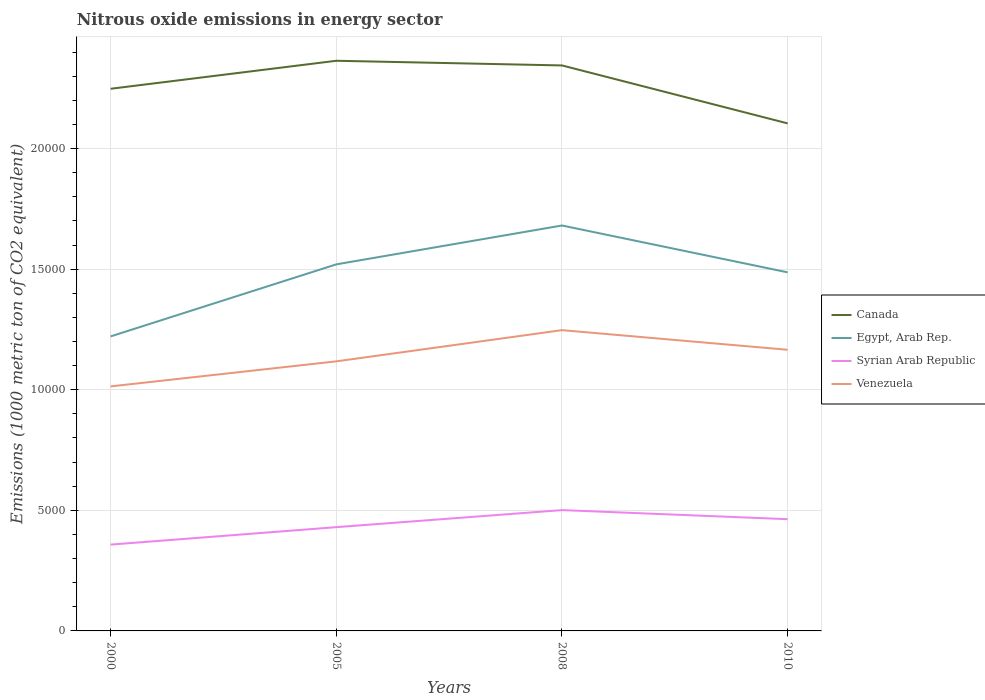Across all years, what is the maximum amount of nitrous oxide emitted in Egypt, Arab Rep.?
Give a very brief answer. 1.22e+04. In which year was the amount of nitrous oxide emitted in Venezuela maximum?
Your answer should be compact. 2000. What is the total amount of nitrous oxide emitted in Venezuela in the graph?
Provide a short and direct response. -1518.6. What is the difference between the highest and the second highest amount of nitrous oxide emitted in Venezuela?
Provide a short and direct response. 2332.1. How many years are there in the graph?
Provide a short and direct response. 4. What is the difference between two consecutive major ticks on the Y-axis?
Offer a terse response. 5000. Where does the legend appear in the graph?
Ensure brevity in your answer.  Center right. How many legend labels are there?
Offer a terse response. 4. What is the title of the graph?
Keep it short and to the point. Nitrous oxide emissions in energy sector. What is the label or title of the X-axis?
Provide a succinct answer. Years. What is the label or title of the Y-axis?
Give a very brief answer. Emissions (1000 metric ton of CO2 equivalent). What is the Emissions (1000 metric ton of CO2 equivalent) in Canada in 2000?
Provide a short and direct response. 2.25e+04. What is the Emissions (1000 metric ton of CO2 equivalent) in Egypt, Arab Rep. in 2000?
Your answer should be compact. 1.22e+04. What is the Emissions (1000 metric ton of CO2 equivalent) of Syrian Arab Republic in 2000?
Provide a succinct answer. 3579.1. What is the Emissions (1000 metric ton of CO2 equivalent) of Venezuela in 2000?
Provide a succinct answer. 1.01e+04. What is the Emissions (1000 metric ton of CO2 equivalent) in Canada in 2005?
Offer a very short reply. 2.36e+04. What is the Emissions (1000 metric ton of CO2 equivalent) in Egypt, Arab Rep. in 2005?
Provide a short and direct response. 1.52e+04. What is the Emissions (1000 metric ton of CO2 equivalent) in Syrian Arab Republic in 2005?
Offer a very short reply. 4302.7. What is the Emissions (1000 metric ton of CO2 equivalent) in Venezuela in 2005?
Offer a terse response. 1.12e+04. What is the Emissions (1000 metric ton of CO2 equivalent) in Canada in 2008?
Keep it short and to the point. 2.34e+04. What is the Emissions (1000 metric ton of CO2 equivalent) in Egypt, Arab Rep. in 2008?
Make the answer very short. 1.68e+04. What is the Emissions (1000 metric ton of CO2 equivalent) in Syrian Arab Republic in 2008?
Ensure brevity in your answer.  5009.9. What is the Emissions (1000 metric ton of CO2 equivalent) of Venezuela in 2008?
Your answer should be very brief. 1.25e+04. What is the Emissions (1000 metric ton of CO2 equivalent) in Canada in 2010?
Your answer should be compact. 2.10e+04. What is the Emissions (1000 metric ton of CO2 equivalent) of Egypt, Arab Rep. in 2010?
Offer a very short reply. 1.49e+04. What is the Emissions (1000 metric ton of CO2 equivalent) in Syrian Arab Republic in 2010?
Your response must be concise. 4633.1. What is the Emissions (1000 metric ton of CO2 equivalent) of Venezuela in 2010?
Make the answer very short. 1.17e+04. Across all years, what is the maximum Emissions (1000 metric ton of CO2 equivalent) in Canada?
Provide a short and direct response. 2.36e+04. Across all years, what is the maximum Emissions (1000 metric ton of CO2 equivalent) in Egypt, Arab Rep.?
Provide a short and direct response. 1.68e+04. Across all years, what is the maximum Emissions (1000 metric ton of CO2 equivalent) in Syrian Arab Republic?
Offer a very short reply. 5009.9. Across all years, what is the maximum Emissions (1000 metric ton of CO2 equivalent) in Venezuela?
Your answer should be compact. 1.25e+04. Across all years, what is the minimum Emissions (1000 metric ton of CO2 equivalent) in Canada?
Your answer should be very brief. 2.10e+04. Across all years, what is the minimum Emissions (1000 metric ton of CO2 equivalent) of Egypt, Arab Rep.?
Your answer should be very brief. 1.22e+04. Across all years, what is the minimum Emissions (1000 metric ton of CO2 equivalent) of Syrian Arab Republic?
Provide a short and direct response. 3579.1. Across all years, what is the minimum Emissions (1000 metric ton of CO2 equivalent) of Venezuela?
Provide a short and direct response. 1.01e+04. What is the total Emissions (1000 metric ton of CO2 equivalent) in Canada in the graph?
Your answer should be very brief. 9.06e+04. What is the total Emissions (1000 metric ton of CO2 equivalent) in Egypt, Arab Rep. in the graph?
Provide a succinct answer. 5.91e+04. What is the total Emissions (1000 metric ton of CO2 equivalent) in Syrian Arab Republic in the graph?
Your response must be concise. 1.75e+04. What is the total Emissions (1000 metric ton of CO2 equivalent) of Venezuela in the graph?
Provide a succinct answer. 4.54e+04. What is the difference between the Emissions (1000 metric ton of CO2 equivalent) in Canada in 2000 and that in 2005?
Make the answer very short. -1161.2. What is the difference between the Emissions (1000 metric ton of CO2 equivalent) of Egypt, Arab Rep. in 2000 and that in 2005?
Your response must be concise. -2987.6. What is the difference between the Emissions (1000 metric ton of CO2 equivalent) of Syrian Arab Republic in 2000 and that in 2005?
Make the answer very short. -723.6. What is the difference between the Emissions (1000 metric ton of CO2 equivalent) in Venezuela in 2000 and that in 2005?
Your answer should be very brief. -1038.4. What is the difference between the Emissions (1000 metric ton of CO2 equivalent) in Canada in 2000 and that in 2008?
Provide a succinct answer. -967.5. What is the difference between the Emissions (1000 metric ton of CO2 equivalent) in Egypt, Arab Rep. in 2000 and that in 2008?
Provide a short and direct response. -4599. What is the difference between the Emissions (1000 metric ton of CO2 equivalent) in Syrian Arab Republic in 2000 and that in 2008?
Make the answer very short. -1430.8. What is the difference between the Emissions (1000 metric ton of CO2 equivalent) in Venezuela in 2000 and that in 2008?
Ensure brevity in your answer.  -2332.1. What is the difference between the Emissions (1000 metric ton of CO2 equivalent) in Canada in 2000 and that in 2010?
Make the answer very short. 1435.7. What is the difference between the Emissions (1000 metric ton of CO2 equivalent) of Egypt, Arab Rep. in 2000 and that in 2010?
Offer a terse response. -2656.4. What is the difference between the Emissions (1000 metric ton of CO2 equivalent) in Syrian Arab Republic in 2000 and that in 2010?
Your answer should be very brief. -1054. What is the difference between the Emissions (1000 metric ton of CO2 equivalent) in Venezuela in 2000 and that in 2010?
Your answer should be very brief. -1518.6. What is the difference between the Emissions (1000 metric ton of CO2 equivalent) of Canada in 2005 and that in 2008?
Your answer should be very brief. 193.7. What is the difference between the Emissions (1000 metric ton of CO2 equivalent) of Egypt, Arab Rep. in 2005 and that in 2008?
Offer a very short reply. -1611.4. What is the difference between the Emissions (1000 metric ton of CO2 equivalent) in Syrian Arab Republic in 2005 and that in 2008?
Your answer should be compact. -707.2. What is the difference between the Emissions (1000 metric ton of CO2 equivalent) in Venezuela in 2005 and that in 2008?
Give a very brief answer. -1293.7. What is the difference between the Emissions (1000 metric ton of CO2 equivalent) in Canada in 2005 and that in 2010?
Your answer should be compact. 2596.9. What is the difference between the Emissions (1000 metric ton of CO2 equivalent) of Egypt, Arab Rep. in 2005 and that in 2010?
Your answer should be very brief. 331.2. What is the difference between the Emissions (1000 metric ton of CO2 equivalent) of Syrian Arab Republic in 2005 and that in 2010?
Make the answer very short. -330.4. What is the difference between the Emissions (1000 metric ton of CO2 equivalent) in Venezuela in 2005 and that in 2010?
Your answer should be very brief. -480.2. What is the difference between the Emissions (1000 metric ton of CO2 equivalent) in Canada in 2008 and that in 2010?
Your answer should be compact. 2403.2. What is the difference between the Emissions (1000 metric ton of CO2 equivalent) of Egypt, Arab Rep. in 2008 and that in 2010?
Your answer should be very brief. 1942.6. What is the difference between the Emissions (1000 metric ton of CO2 equivalent) in Syrian Arab Republic in 2008 and that in 2010?
Offer a terse response. 376.8. What is the difference between the Emissions (1000 metric ton of CO2 equivalent) in Venezuela in 2008 and that in 2010?
Provide a succinct answer. 813.5. What is the difference between the Emissions (1000 metric ton of CO2 equivalent) in Canada in 2000 and the Emissions (1000 metric ton of CO2 equivalent) in Egypt, Arab Rep. in 2005?
Your response must be concise. 7280.8. What is the difference between the Emissions (1000 metric ton of CO2 equivalent) of Canada in 2000 and the Emissions (1000 metric ton of CO2 equivalent) of Syrian Arab Republic in 2005?
Keep it short and to the point. 1.82e+04. What is the difference between the Emissions (1000 metric ton of CO2 equivalent) of Canada in 2000 and the Emissions (1000 metric ton of CO2 equivalent) of Venezuela in 2005?
Offer a terse response. 1.13e+04. What is the difference between the Emissions (1000 metric ton of CO2 equivalent) in Egypt, Arab Rep. in 2000 and the Emissions (1000 metric ton of CO2 equivalent) in Syrian Arab Republic in 2005?
Give a very brief answer. 7909.7. What is the difference between the Emissions (1000 metric ton of CO2 equivalent) in Egypt, Arab Rep. in 2000 and the Emissions (1000 metric ton of CO2 equivalent) in Venezuela in 2005?
Offer a terse response. 1034.4. What is the difference between the Emissions (1000 metric ton of CO2 equivalent) of Syrian Arab Republic in 2000 and the Emissions (1000 metric ton of CO2 equivalent) of Venezuela in 2005?
Offer a terse response. -7598.9. What is the difference between the Emissions (1000 metric ton of CO2 equivalent) of Canada in 2000 and the Emissions (1000 metric ton of CO2 equivalent) of Egypt, Arab Rep. in 2008?
Offer a very short reply. 5669.4. What is the difference between the Emissions (1000 metric ton of CO2 equivalent) of Canada in 2000 and the Emissions (1000 metric ton of CO2 equivalent) of Syrian Arab Republic in 2008?
Ensure brevity in your answer.  1.75e+04. What is the difference between the Emissions (1000 metric ton of CO2 equivalent) in Canada in 2000 and the Emissions (1000 metric ton of CO2 equivalent) in Venezuela in 2008?
Your response must be concise. 1.00e+04. What is the difference between the Emissions (1000 metric ton of CO2 equivalent) of Egypt, Arab Rep. in 2000 and the Emissions (1000 metric ton of CO2 equivalent) of Syrian Arab Republic in 2008?
Your answer should be very brief. 7202.5. What is the difference between the Emissions (1000 metric ton of CO2 equivalent) in Egypt, Arab Rep. in 2000 and the Emissions (1000 metric ton of CO2 equivalent) in Venezuela in 2008?
Give a very brief answer. -259.3. What is the difference between the Emissions (1000 metric ton of CO2 equivalent) in Syrian Arab Republic in 2000 and the Emissions (1000 metric ton of CO2 equivalent) in Venezuela in 2008?
Your response must be concise. -8892.6. What is the difference between the Emissions (1000 metric ton of CO2 equivalent) in Canada in 2000 and the Emissions (1000 metric ton of CO2 equivalent) in Egypt, Arab Rep. in 2010?
Keep it short and to the point. 7612. What is the difference between the Emissions (1000 metric ton of CO2 equivalent) in Canada in 2000 and the Emissions (1000 metric ton of CO2 equivalent) in Syrian Arab Republic in 2010?
Offer a terse response. 1.78e+04. What is the difference between the Emissions (1000 metric ton of CO2 equivalent) in Canada in 2000 and the Emissions (1000 metric ton of CO2 equivalent) in Venezuela in 2010?
Your answer should be very brief. 1.08e+04. What is the difference between the Emissions (1000 metric ton of CO2 equivalent) of Egypt, Arab Rep. in 2000 and the Emissions (1000 metric ton of CO2 equivalent) of Syrian Arab Republic in 2010?
Provide a short and direct response. 7579.3. What is the difference between the Emissions (1000 metric ton of CO2 equivalent) of Egypt, Arab Rep. in 2000 and the Emissions (1000 metric ton of CO2 equivalent) of Venezuela in 2010?
Your answer should be compact. 554.2. What is the difference between the Emissions (1000 metric ton of CO2 equivalent) in Syrian Arab Republic in 2000 and the Emissions (1000 metric ton of CO2 equivalent) in Venezuela in 2010?
Your answer should be compact. -8079.1. What is the difference between the Emissions (1000 metric ton of CO2 equivalent) in Canada in 2005 and the Emissions (1000 metric ton of CO2 equivalent) in Egypt, Arab Rep. in 2008?
Provide a succinct answer. 6830.6. What is the difference between the Emissions (1000 metric ton of CO2 equivalent) of Canada in 2005 and the Emissions (1000 metric ton of CO2 equivalent) of Syrian Arab Republic in 2008?
Your answer should be compact. 1.86e+04. What is the difference between the Emissions (1000 metric ton of CO2 equivalent) in Canada in 2005 and the Emissions (1000 metric ton of CO2 equivalent) in Venezuela in 2008?
Keep it short and to the point. 1.12e+04. What is the difference between the Emissions (1000 metric ton of CO2 equivalent) of Egypt, Arab Rep. in 2005 and the Emissions (1000 metric ton of CO2 equivalent) of Syrian Arab Republic in 2008?
Give a very brief answer. 1.02e+04. What is the difference between the Emissions (1000 metric ton of CO2 equivalent) in Egypt, Arab Rep. in 2005 and the Emissions (1000 metric ton of CO2 equivalent) in Venezuela in 2008?
Keep it short and to the point. 2728.3. What is the difference between the Emissions (1000 metric ton of CO2 equivalent) in Syrian Arab Republic in 2005 and the Emissions (1000 metric ton of CO2 equivalent) in Venezuela in 2008?
Make the answer very short. -8169. What is the difference between the Emissions (1000 metric ton of CO2 equivalent) of Canada in 2005 and the Emissions (1000 metric ton of CO2 equivalent) of Egypt, Arab Rep. in 2010?
Offer a very short reply. 8773.2. What is the difference between the Emissions (1000 metric ton of CO2 equivalent) in Canada in 2005 and the Emissions (1000 metric ton of CO2 equivalent) in Syrian Arab Republic in 2010?
Provide a succinct answer. 1.90e+04. What is the difference between the Emissions (1000 metric ton of CO2 equivalent) of Canada in 2005 and the Emissions (1000 metric ton of CO2 equivalent) of Venezuela in 2010?
Your answer should be compact. 1.20e+04. What is the difference between the Emissions (1000 metric ton of CO2 equivalent) in Egypt, Arab Rep. in 2005 and the Emissions (1000 metric ton of CO2 equivalent) in Syrian Arab Republic in 2010?
Make the answer very short. 1.06e+04. What is the difference between the Emissions (1000 metric ton of CO2 equivalent) of Egypt, Arab Rep. in 2005 and the Emissions (1000 metric ton of CO2 equivalent) of Venezuela in 2010?
Provide a succinct answer. 3541.8. What is the difference between the Emissions (1000 metric ton of CO2 equivalent) of Syrian Arab Republic in 2005 and the Emissions (1000 metric ton of CO2 equivalent) of Venezuela in 2010?
Your answer should be compact. -7355.5. What is the difference between the Emissions (1000 metric ton of CO2 equivalent) in Canada in 2008 and the Emissions (1000 metric ton of CO2 equivalent) in Egypt, Arab Rep. in 2010?
Provide a short and direct response. 8579.5. What is the difference between the Emissions (1000 metric ton of CO2 equivalent) in Canada in 2008 and the Emissions (1000 metric ton of CO2 equivalent) in Syrian Arab Republic in 2010?
Provide a short and direct response. 1.88e+04. What is the difference between the Emissions (1000 metric ton of CO2 equivalent) of Canada in 2008 and the Emissions (1000 metric ton of CO2 equivalent) of Venezuela in 2010?
Your answer should be very brief. 1.18e+04. What is the difference between the Emissions (1000 metric ton of CO2 equivalent) of Egypt, Arab Rep. in 2008 and the Emissions (1000 metric ton of CO2 equivalent) of Syrian Arab Republic in 2010?
Offer a terse response. 1.22e+04. What is the difference between the Emissions (1000 metric ton of CO2 equivalent) in Egypt, Arab Rep. in 2008 and the Emissions (1000 metric ton of CO2 equivalent) in Venezuela in 2010?
Provide a succinct answer. 5153.2. What is the difference between the Emissions (1000 metric ton of CO2 equivalent) of Syrian Arab Republic in 2008 and the Emissions (1000 metric ton of CO2 equivalent) of Venezuela in 2010?
Offer a very short reply. -6648.3. What is the average Emissions (1000 metric ton of CO2 equivalent) of Canada per year?
Ensure brevity in your answer.  2.27e+04. What is the average Emissions (1000 metric ton of CO2 equivalent) of Egypt, Arab Rep. per year?
Provide a short and direct response. 1.48e+04. What is the average Emissions (1000 metric ton of CO2 equivalent) of Syrian Arab Republic per year?
Give a very brief answer. 4381.2. What is the average Emissions (1000 metric ton of CO2 equivalent) of Venezuela per year?
Your answer should be compact. 1.14e+04. In the year 2000, what is the difference between the Emissions (1000 metric ton of CO2 equivalent) of Canada and Emissions (1000 metric ton of CO2 equivalent) of Egypt, Arab Rep.?
Provide a short and direct response. 1.03e+04. In the year 2000, what is the difference between the Emissions (1000 metric ton of CO2 equivalent) in Canada and Emissions (1000 metric ton of CO2 equivalent) in Syrian Arab Republic?
Offer a very short reply. 1.89e+04. In the year 2000, what is the difference between the Emissions (1000 metric ton of CO2 equivalent) in Canada and Emissions (1000 metric ton of CO2 equivalent) in Venezuela?
Make the answer very short. 1.23e+04. In the year 2000, what is the difference between the Emissions (1000 metric ton of CO2 equivalent) of Egypt, Arab Rep. and Emissions (1000 metric ton of CO2 equivalent) of Syrian Arab Republic?
Provide a succinct answer. 8633.3. In the year 2000, what is the difference between the Emissions (1000 metric ton of CO2 equivalent) of Egypt, Arab Rep. and Emissions (1000 metric ton of CO2 equivalent) of Venezuela?
Keep it short and to the point. 2072.8. In the year 2000, what is the difference between the Emissions (1000 metric ton of CO2 equivalent) in Syrian Arab Republic and Emissions (1000 metric ton of CO2 equivalent) in Venezuela?
Offer a terse response. -6560.5. In the year 2005, what is the difference between the Emissions (1000 metric ton of CO2 equivalent) in Canada and Emissions (1000 metric ton of CO2 equivalent) in Egypt, Arab Rep.?
Offer a very short reply. 8442. In the year 2005, what is the difference between the Emissions (1000 metric ton of CO2 equivalent) in Canada and Emissions (1000 metric ton of CO2 equivalent) in Syrian Arab Republic?
Your answer should be very brief. 1.93e+04. In the year 2005, what is the difference between the Emissions (1000 metric ton of CO2 equivalent) of Canada and Emissions (1000 metric ton of CO2 equivalent) of Venezuela?
Make the answer very short. 1.25e+04. In the year 2005, what is the difference between the Emissions (1000 metric ton of CO2 equivalent) in Egypt, Arab Rep. and Emissions (1000 metric ton of CO2 equivalent) in Syrian Arab Republic?
Offer a terse response. 1.09e+04. In the year 2005, what is the difference between the Emissions (1000 metric ton of CO2 equivalent) in Egypt, Arab Rep. and Emissions (1000 metric ton of CO2 equivalent) in Venezuela?
Ensure brevity in your answer.  4022. In the year 2005, what is the difference between the Emissions (1000 metric ton of CO2 equivalent) in Syrian Arab Republic and Emissions (1000 metric ton of CO2 equivalent) in Venezuela?
Offer a terse response. -6875.3. In the year 2008, what is the difference between the Emissions (1000 metric ton of CO2 equivalent) in Canada and Emissions (1000 metric ton of CO2 equivalent) in Egypt, Arab Rep.?
Keep it short and to the point. 6636.9. In the year 2008, what is the difference between the Emissions (1000 metric ton of CO2 equivalent) of Canada and Emissions (1000 metric ton of CO2 equivalent) of Syrian Arab Republic?
Offer a very short reply. 1.84e+04. In the year 2008, what is the difference between the Emissions (1000 metric ton of CO2 equivalent) in Canada and Emissions (1000 metric ton of CO2 equivalent) in Venezuela?
Keep it short and to the point. 1.10e+04. In the year 2008, what is the difference between the Emissions (1000 metric ton of CO2 equivalent) of Egypt, Arab Rep. and Emissions (1000 metric ton of CO2 equivalent) of Syrian Arab Republic?
Provide a short and direct response. 1.18e+04. In the year 2008, what is the difference between the Emissions (1000 metric ton of CO2 equivalent) of Egypt, Arab Rep. and Emissions (1000 metric ton of CO2 equivalent) of Venezuela?
Offer a terse response. 4339.7. In the year 2008, what is the difference between the Emissions (1000 metric ton of CO2 equivalent) of Syrian Arab Republic and Emissions (1000 metric ton of CO2 equivalent) of Venezuela?
Provide a succinct answer. -7461.8. In the year 2010, what is the difference between the Emissions (1000 metric ton of CO2 equivalent) in Canada and Emissions (1000 metric ton of CO2 equivalent) in Egypt, Arab Rep.?
Keep it short and to the point. 6176.3. In the year 2010, what is the difference between the Emissions (1000 metric ton of CO2 equivalent) of Canada and Emissions (1000 metric ton of CO2 equivalent) of Syrian Arab Republic?
Give a very brief answer. 1.64e+04. In the year 2010, what is the difference between the Emissions (1000 metric ton of CO2 equivalent) in Canada and Emissions (1000 metric ton of CO2 equivalent) in Venezuela?
Give a very brief answer. 9386.9. In the year 2010, what is the difference between the Emissions (1000 metric ton of CO2 equivalent) in Egypt, Arab Rep. and Emissions (1000 metric ton of CO2 equivalent) in Syrian Arab Republic?
Offer a terse response. 1.02e+04. In the year 2010, what is the difference between the Emissions (1000 metric ton of CO2 equivalent) of Egypt, Arab Rep. and Emissions (1000 metric ton of CO2 equivalent) of Venezuela?
Your answer should be compact. 3210.6. In the year 2010, what is the difference between the Emissions (1000 metric ton of CO2 equivalent) in Syrian Arab Republic and Emissions (1000 metric ton of CO2 equivalent) in Venezuela?
Make the answer very short. -7025.1. What is the ratio of the Emissions (1000 metric ton of CO2 equivalent) in Canada in 2000 to that in 2005?
Your answer should be very brief. 0.95. What is the ratio of the Emissions (1000 metric ton of CO2 equivalent) of Egypt, Arab Rep. in 2000 to that in 2005?
Give a very brief answer. 0.8. What is the ratio of the Emissions (1000 metric ton of CO2 equivalent) of Syrian Arab Republic in 2000 to that in 2005?
Your answer should be very brief. 0.83. What is the ratio of the Emissions (1000 metric ton of CO2 equivalent) of Venezuela in 2000 to that in 2005?
Offer a terse response. 0.91. What is the ratio of the Emissions (1000 metric ton of CO2 equivalent) in Canada in 2000 to that in 2008?
Ensure brevity in your answer.  0.96. What is the ratio of the Emissions (1000 metric ton of CO2 equivalent) in Egypt, Arab Rep. in 2000 to that in 2008?
Your answer should be very brief. 0.73. What is the ratio of the Emissions (1000 metric ton of CO2 equivalent) in Syrian Arab Republic in 2000 to that in 2008?
Your answer should be very brief. 0.71. What is the ratio of the Emissions (1000 metric ton of CO2 equivalent) of Venezuela in 2000 to that in 2008?
Your answer should be compact. 0.81. What is the ratio of the Emissions (1000 metric ton of CO2 equivalent) of Canada in 2000 to that in 2010?
Your answer should be very brief. 1.07. What is the ratio of the Emissions (1000 metric ton of CO2 equivalent) in Egypt, Arab Rep. in 2000 to that in 2010?
Your answer should be compact. 0.82. What is the ratio of the Emissions (1000 metric ton of CO2 equivalent) in Syrian Arab Republic in 2000 to that in 2010?
Ensure brevity in your answer.  0.77. What is the ratio of the Emissions (1000 metric ton of CO2 equivalent) of Venezuela in 2000 to that in 2010?
Provide a succinct answer. 0.87. What is the ratio of the Emissions (1000 metric ton of CO2 equivalent) in Canada in 2005 to that in 2008?
Provide a short and direct response. 1.01. What is the ratio of the Emissions (1000 metric ton of CO2 equivalent) in Egypt, Arab Rep. in 2005 to that in 2008?
Your answer should be very brief. 0.9. What is the ratio of the Emissions (1000 metric ton of CO2 equivalent) in Syrian Arab Republic in 2005 to that in 2008?
Your answer should be compact. 0.86. What is the ratio of the Emissions (1000 metric ton of CO2 equivalent) of Venezuela in 2005 to that in 2008?
Ensure brevity in your answer.  0.9. What is the ratio of the Emissions (1000 metric ton of CO2 equivalent) in Canada in 2005 to that in 2010?
Offer a terse response. 1.12. What is the ratio of the Emissions (1000 metric ton of CO2 equivalent) in Egypt, Arab Rep. in 2005 to that in 2010?
Provide a succinct answer. 1.02. What is the ratio of the Emissions (1000 metric ton of CO2 equivalent) of Syrian Arab Republic in 2005 to that in 2010?
Your response must be concise. 0.93. What is the ratio of the Emissions (1000 metric ton of CO2 equivalent) of Venezuela in 2005 to that in 2010?
Keep it short and to the point. 0.96. What is the ratio of the Emissions (1000 metric ton of CO2 equivalent) in Canada in 2008 to that in 2010?
Make the answer very short. 1.11. What is the ratio of the Emissions (1000 metric ton of CO2 equivalent) in Egypt, Arab Rep. in 2008 to that in 2010?
Give a very brief answer. 1.13. What is the ratio of the Emissions (1000 metric ton of CO2 equivalent) in Syrian Arab Republic in 2008 to that in 2010?
Give a very brief answer. 1.08. What is the ratio of the Emissions (1000 metric ton of CO2 equivalent) of Venezuela in 2008 to that in 2010?
Provide a succinct answer. 1.07. What is the difference between the highest and the second highest Emissions (1000 metric ton of CO2 equivalent) in Canada?
Make the answer very short. 193.7. What is the difference between the highest and the second highest Emissions (1000 metric ton of CO2 equivalent) in Egypt, Arab Rep.?
Give a very brief answer. 1611.4. What is the difference between the highest and the second highest Emissions (1000 metric ton of CO2 equivalent) of Syrian Arab Republic?
Ensure brevity in your answer.  376.8. What is the difference between the highest and the second highest Emissions (1000 metric ton of CO2 equivalent) of Venezuela?
Ensure brevity in your answer.  813.5. What is the difference between the highest and the lowest Emissions (1000 metric ton of CO2 equivalent) of Canada?
Offer a terse response. 2596.9. What is the difference between the highest and the lowest Emissions (1000 metric ton of CO2 equivalent) of Egypt, Arab Rep.?
Keep it short and to the point. 4599. What is the difference between the highest and the lowest Emissions (1000 metric ton of CO2 equivalent) in Syrian Arab Republic?
Provide a short and direct response. 1430.8. What is the difference between the highest and the lowest Emissions (1000 metric ton of CO2 equivalent) in Venezuela?
Your answer should be very brief. 2332.1. 